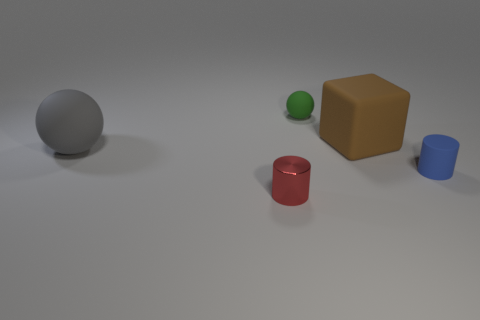Are there any other things that are made of the same material as the small red thing?
Provide a succinct answer. No. There is a tiny object that is behind the large thing that is to the left of the big brown cube; what is its color?
Your answer should be compact. Green. There is another large thing that is the same shape as the green object; what is its color?
Provide a succinct answer. Gray. How many tiny metal cylinders have the same color as the small ball?
Offer a very short reply. 0. What is the shape of the rubber object that is both in front of the cube and behind the blue rubber object?
Offer a very short reply. Sphere. There is a small cylinder in front of the small cylinder that is on the right side of the sphere that is behind the big cube; what is it made of?
Your response must be concise. Metal. Is the number of things that are in front of the tiny matte cylinder greater than the number of brown matte objects in front of the large brown matte block?
Your response must be concise. Yes. What number of green balls are made of the same material as the gray ball?
Provide a short and direct response. 1. There is a big thing right of the tiny green thing; does it have the same shape as the object left of the tiny red metal cylinder?
Provide a short and direct response. No. There is a large matte thing that is left of the small metal thing; what color is it?
Your response must be concise. Gray. 